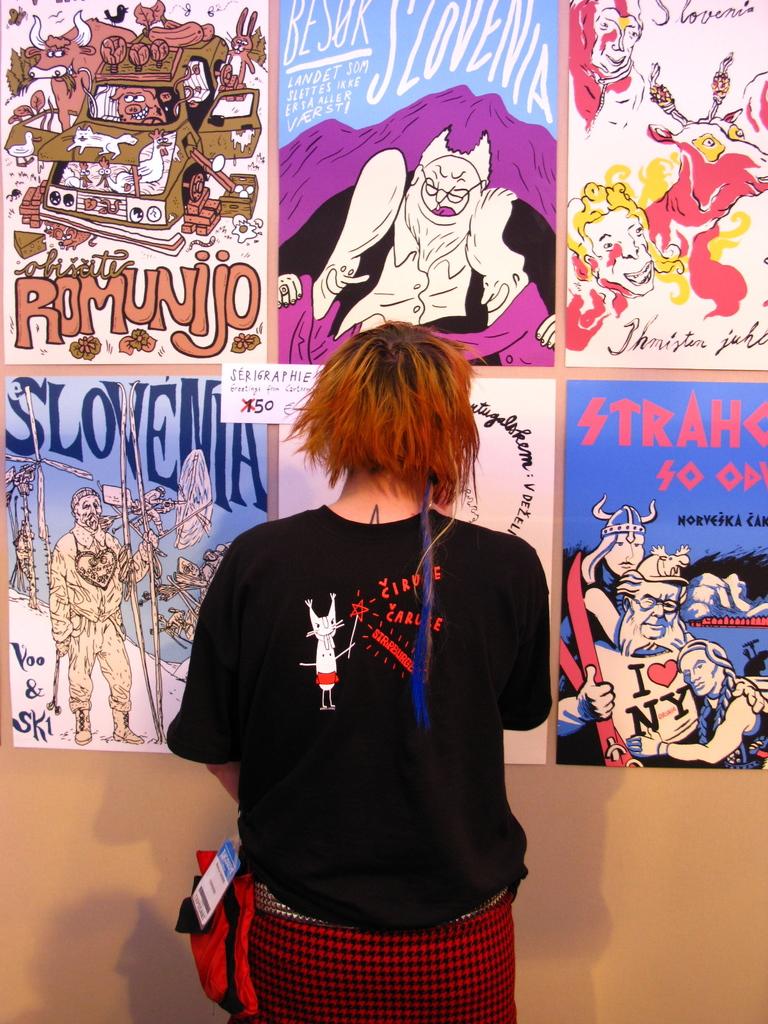What do the vikings love in the lower left comic?
Provide a succinct answer. Slovenia. What is written on the poster on the bottom right hand corner?
Offer a very short reply. I love ny. 